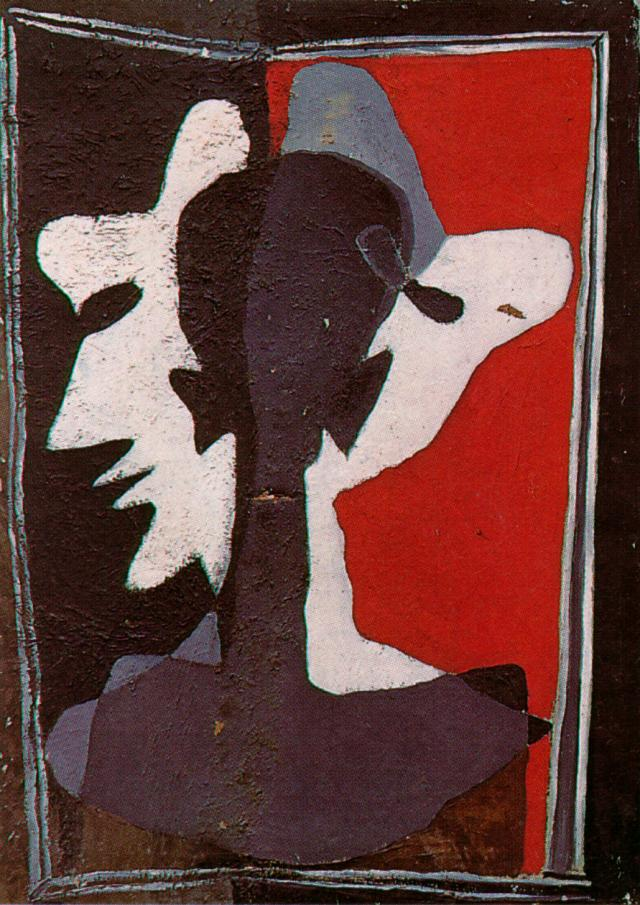What might this artwork look like if transformed into a living entity? If this artwork were transformed into a living entity, it would likely be a spectral being, constantly shifting and evolving in form. Its body would be composed of intertwining shadows and lights, creating a mesmerizing dance of contrast. The red aura around it would pulse rhythmically, reflecting its emotional state. Its face, or rather, faces, would morph between different expressions, portraying a complex, multi-faceted identity. This entity would move gracefully across the ground, leaving a trail of textured imprints resembling the rough canvas of its original form. It would communicate through visual poetry, using its changing forms and colors to convey thoughts and emotions in a manner that bridges the gap between the abstract and the tangible.  Pretend you are a historian from the future looking at this image. What historical significance might this artwork hold? As a future historian examining this image, this artwork might hold significant historical importance as a symbol of the early 21st century's emotional and philosophical landscape. Created during a period of rapid technological and cultural change, this piece exemplifies the feelings of fragmentation and redefinition of identity that many experienced during this time. The stark contrasts and layered textures signify the tension between different social and political forces that were prevalent. This artwork stands as a testament to the era's complex human experience, reflecting the inner conflicts and societal dualities that defined it. 